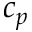Convert formula to latex. <formula><loc_0><loc_0><loc_500><loc_500>c _ { p }</formula> 